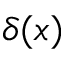<formula> <loc_0><loc_0><loc_500><loc_500>\delta ( x )</formula> 